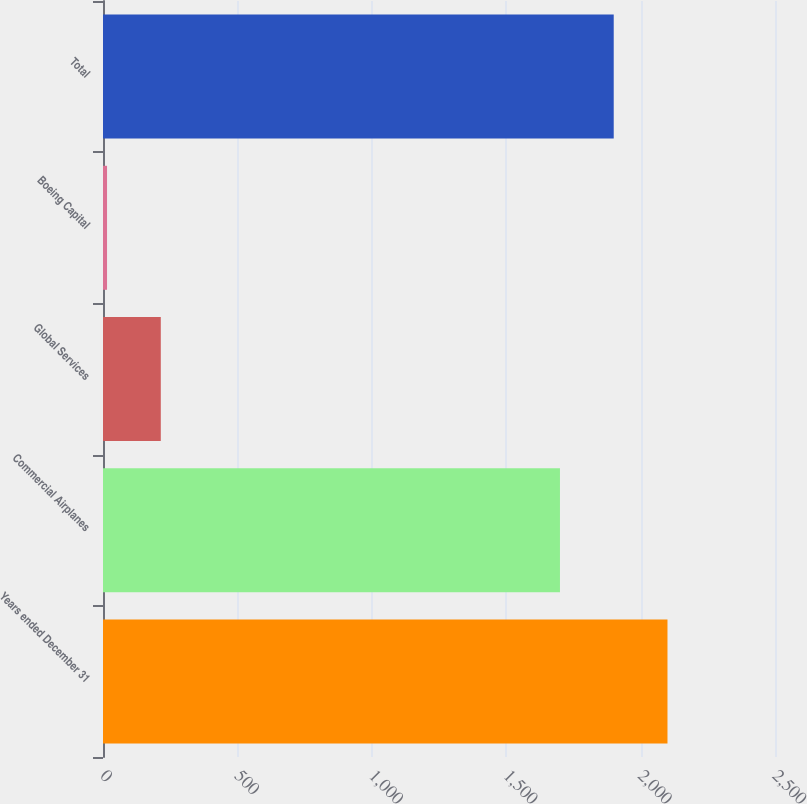Convert chart. <chart><loc_0><loc_0><loc_500><loc_500><bar_chart><fcel>Years ended December 31<fcel>Commercial Airplanes<fcel>Global Services<fcel>Boeing Capital<fcel>Total<nl><fcel>2100<fcel>1700<fcel>215<fcel>15<fcel>1900<nl></chart> 